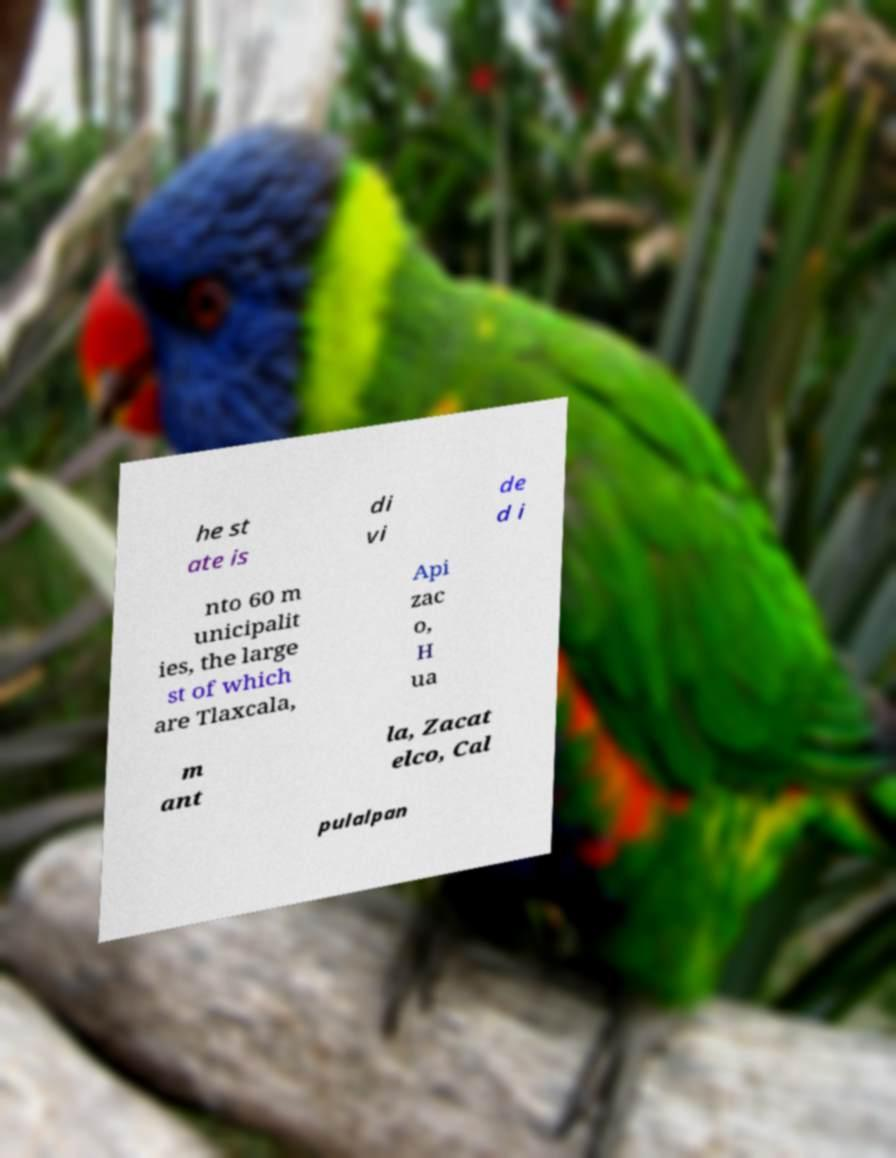Can you accurately transcribe the text from the provided image for me? he st ate is di vi de d i nto 60 m unicipalit ies, the large st of which are Tlaxcala, Api zac o, H ua m ant la, Zacat elco, Cal pulalpan 